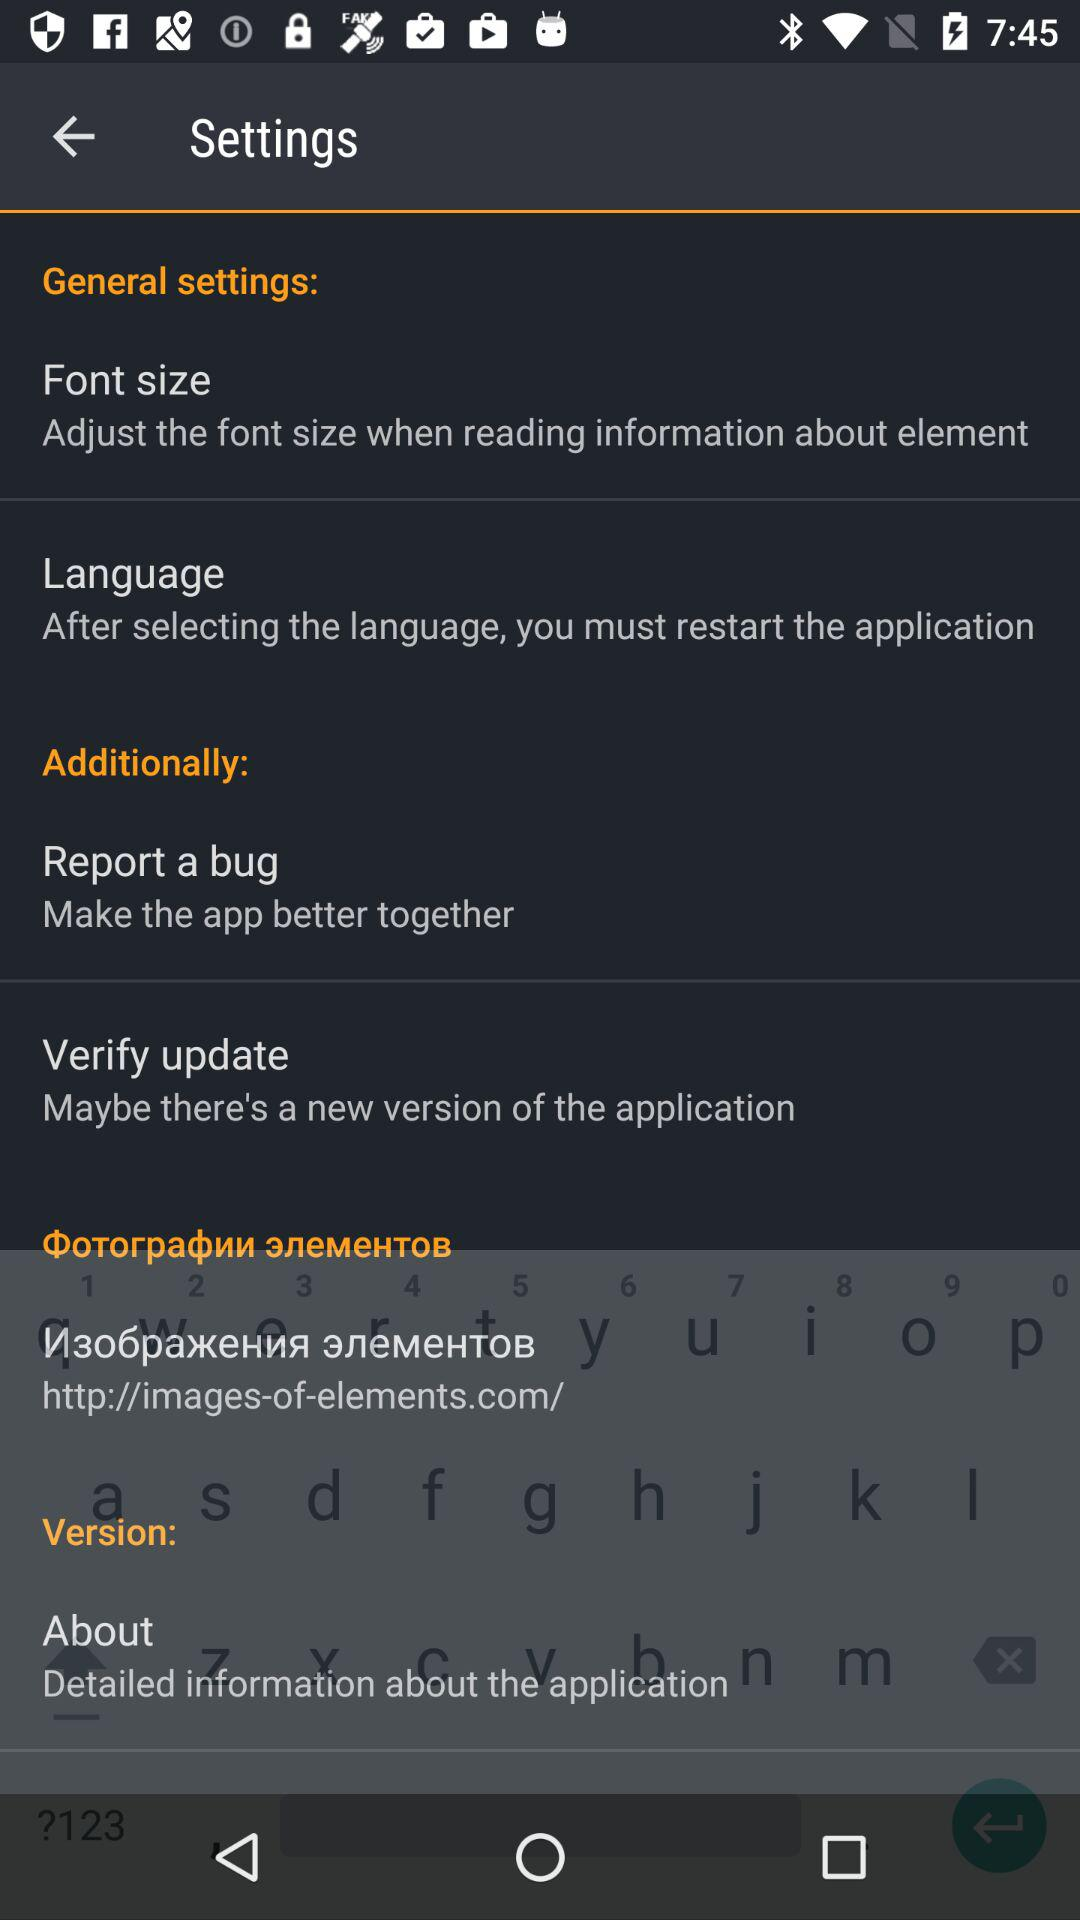How many items are there in the 'General settings' section?
Answer the question using a single word or phrase. 2 